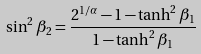Convert formula to latex. <formula><loc_0><loc_0><loc_500><loc_500>\sin ^ { 2 } { \beta _ { 2 } } = \frac { 2 ^ { 1 / \alpha } - 1 - \tanh ^ { 2 } { \beta _ { 1 } } } { 1 - \tanh ^ { 2 } { \beta _ { 1 } } }</formula> 